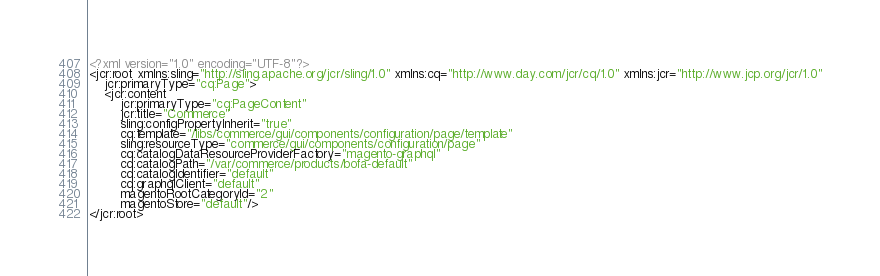Convert code to text. <code><loc_0><loc_0><loc_500><loc_500><_XML_><?xml version="1.0" encoding="UTF-8"?>
<jcr:root xmlns:sling="http://sling.apache.org/jcr/sling/1.0" xmlns:cq="http://www.day.com/jcr/cq/1.0" xmlns:jcr="http://www.jcp.org/jcr/1.0"
    jcr:primaryType="cq:Page">
    <jcr:content
        jcr:primaryType="cq:PageContent"
        jcr:title="Commerce"
        sling:configPropertyInherit="true"
        cq:template="/libs/commerce/gui/components/configuration/page/template"
        sling:resourceType="commerce/gui/components/configuration/page"
        cq:catalogDataResourceProviderFactory="magento-graphql"
        cq:catalogPath="/var/commerce/products/bofa-default"
        cq:catalogIdentifier="default"
        cq:graphqlClient="default"
        magentoRootCategoryId="2"
        magentoStore="default"/>
</jcr:root>
</code> 